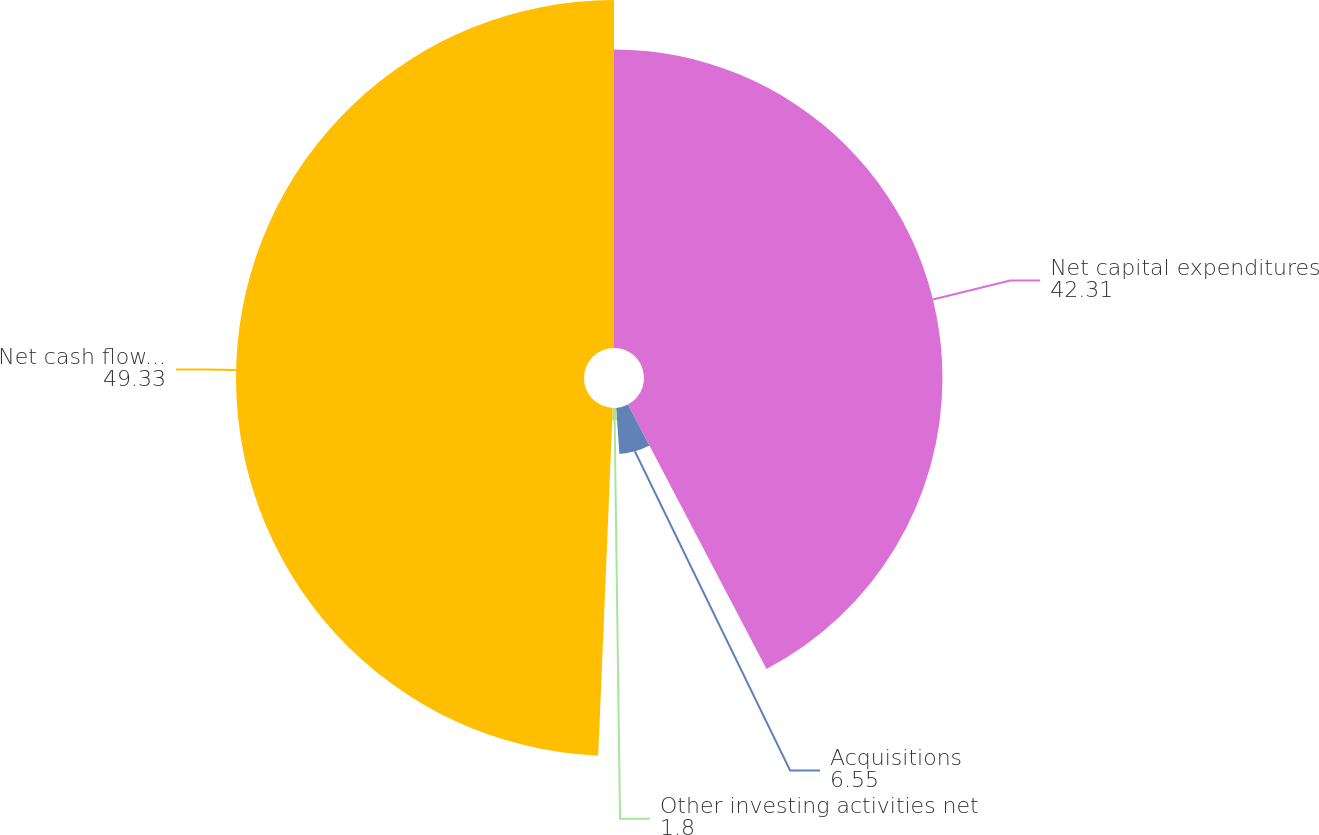<chart> <loc_0><loc_0><loc_500><loc_500><pie_chart><fcel>Net capital expenditures<fcel>Acquisitions<fcel>Other investing activities net<fcel>Net cash flows used in<nl><fcel>42.31%<fcel>6.55%<fcel>1.8%<fcel>49.33%<nl></chart> 